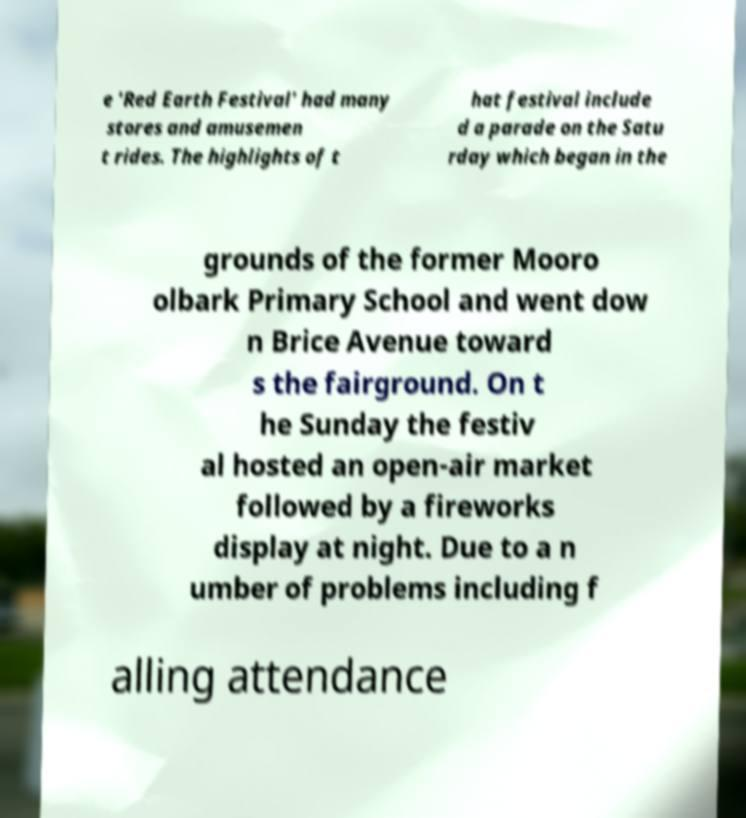What messages or text are displayed in this image? I need them in a readable, typed format. e 'Red Earth Festival' had many stores and amusemen t rides. The highlights of t hat festival include d a parade on the Satu rday which began in the grounds of the former Mooro olbark Primary School and went dow n Brice Avenue toward s the fairground. On t he Sunday the festiv al hosted an open-air market followed by a fireworks display at night. Due to a n umber of problems including f alling attendance 